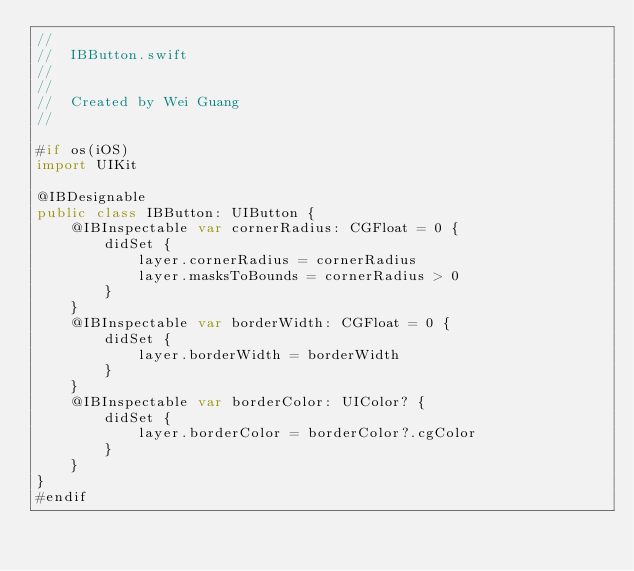Convert code to text. <code><loc_0><loc_0><loc_500><loc_500><_Swift_>//
//  IBButton.swift
//
//
//  Created by Wei Guang
//

#if os(iOS)
import UIKit

@IBDesignable
public class IBButton: UIButton {
    @IBInspectable var cornerRadius: CGFloat = 0 {
        didSet {
            layer.cornerRadius = cornerRadius
            layer.masksToBounds = cornerRadius > 0
        }
    }
    @IBInspectable var borderWidth: CGFloat = 0 {
        didSet {
            layer.borderWidth = borderWidth
        }
    }
    @IBInspectable var borderColor: UIColor? {
        didSet {
            layer.borderColor = borderColor?.cgColor
        }
    }
}
#endif
</code> 